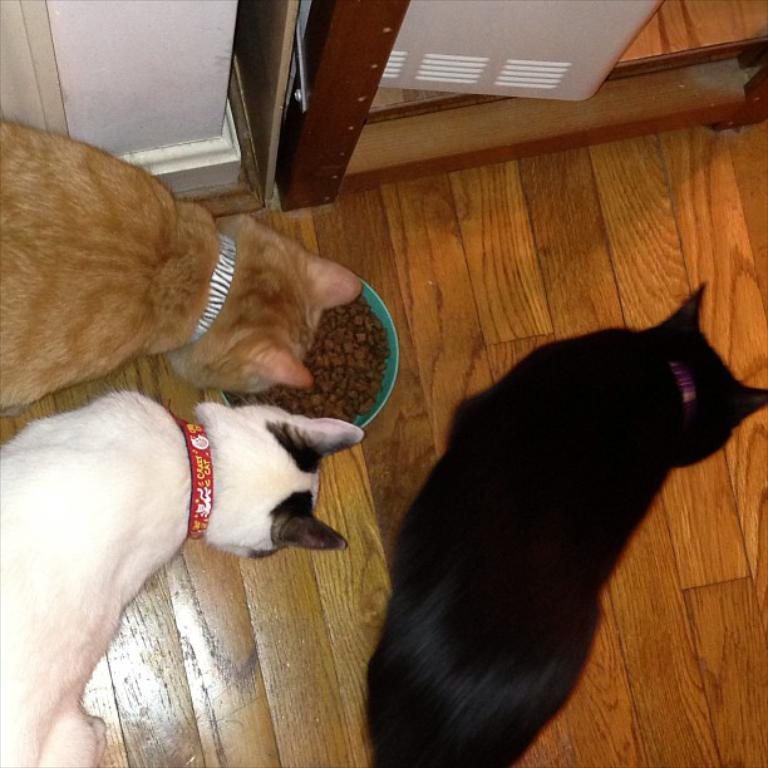What type of animals can be seen in the image? There are dogs in the image. What is in the bowl that is visible in the image? There is a bowl containing food in the image. What type of surface is visible in the image? There is a floor visible in the image. What can be seen in the background of the image? There is a door and a wall in the background of the image. What type of oil can be seen dripping from the dogs in the image? There is no oil present in the image, nor is it dripping from the dogs. 